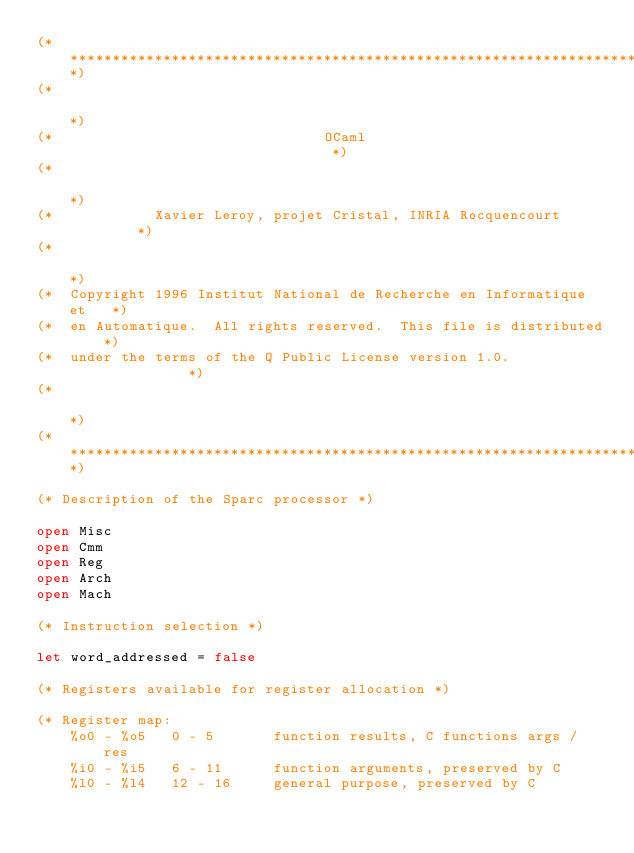<code> <loc_0><loc_0><loc_500><loc_500><_OCaml_>(***********************************************************************)
(*                                                                     *)
(*                                OCaml                                *)
(*                                                                     *)
(*            Xavier Leroy, projet Cristal, INRIA Rocquencourt         *)
(*                                                                     *)
(*  Copyright 1996 Institut National de Recherche en Informatique et   *)
(*  en Automatique.  All rights reserved.  This file is distributed    *)
(*  under the terms of the Q Public License version 1.0.               *)
(*                                                                     *)
(***********************************************************************)

(* Description of the Sparc processor *)

open Misc
open Cmm
open Reg
open Arch
open Mach

(* Instruction selection *)

let word_addressed = false

(* Registers available for register allocation *)

(* Register map:
    %o0 - %o5   0 - 5       function results, C functions args / res
    %i0 - %i5   6 - 11      function arguments, preserved by C
    %l0 - %l4   12 - 16     general purpose, preserved by C</code> 